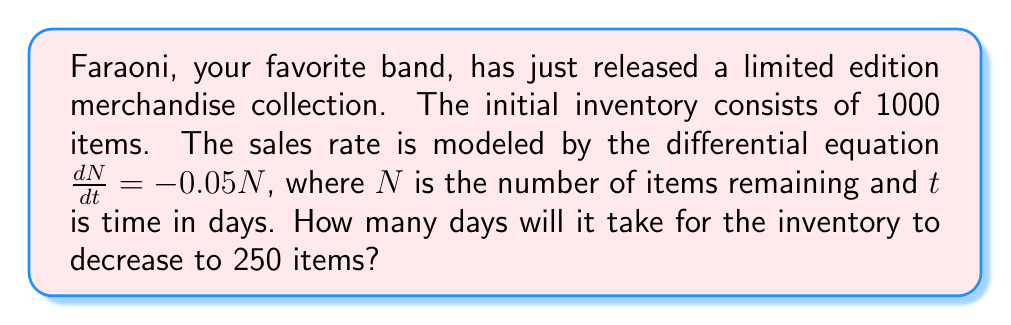Show me your answer to this math problem. To solve this problem, we need to use the given first-order differential equation and initial conditions:

1) The differential equation is $\frac{dN}{dt} = -0.05N$
2) Initial condition: $N(0) = 1000$ (initial inventory)
3) We need to find $t$ when $N(t) = 250$

This is a separable differential equation. Let's solve it step by step:

1) Separate the variables:
   $\frac{dN}{N} = -0.05dt$

2) Integrate both sides:
   $\int \frac{dN}{N} = \int -0.05dt$

3) Solve the integrals:
   $\ln|N| = -0.05t + C$

4) Apply the initial condition $N(0) = 1000$:
   $\ln(1000) = C$

5) Substitute back into the general solution:
   $\ln|N| = -0.05t + \ln(1000)$

6) Simplify:
   $\ln|N| - \ln(1000) = -0.05t$
   $\ln(\frac{N}{1000}) = -0.05t$

7) Apply the exponential function to both sides:
   $\frac{N}{1000} = e^{-0.05t}$

8) Multiply both sides by 1000:
   $N = 1000e^{-0.05t}$

Now, we want to find $t$ when $N = 250$:

9) Substitute $N = 250$:
   $250 = 1000e^{-0.05t}$

10) Divide both sides by 1000:
    $0.25 = e^{-0.05t}$

11) Take the natural log of both sides:
    $\ln(0.25) = -0.05t$

12) Solve for $t$:
    $t = \frac{\ln(0.25)}{-0.05} \approx 27.73$ days

Therefore, it will take approximately 27.73 days for the inventory to decrease to 250 items.
Answer: Approximately 27.73 days 